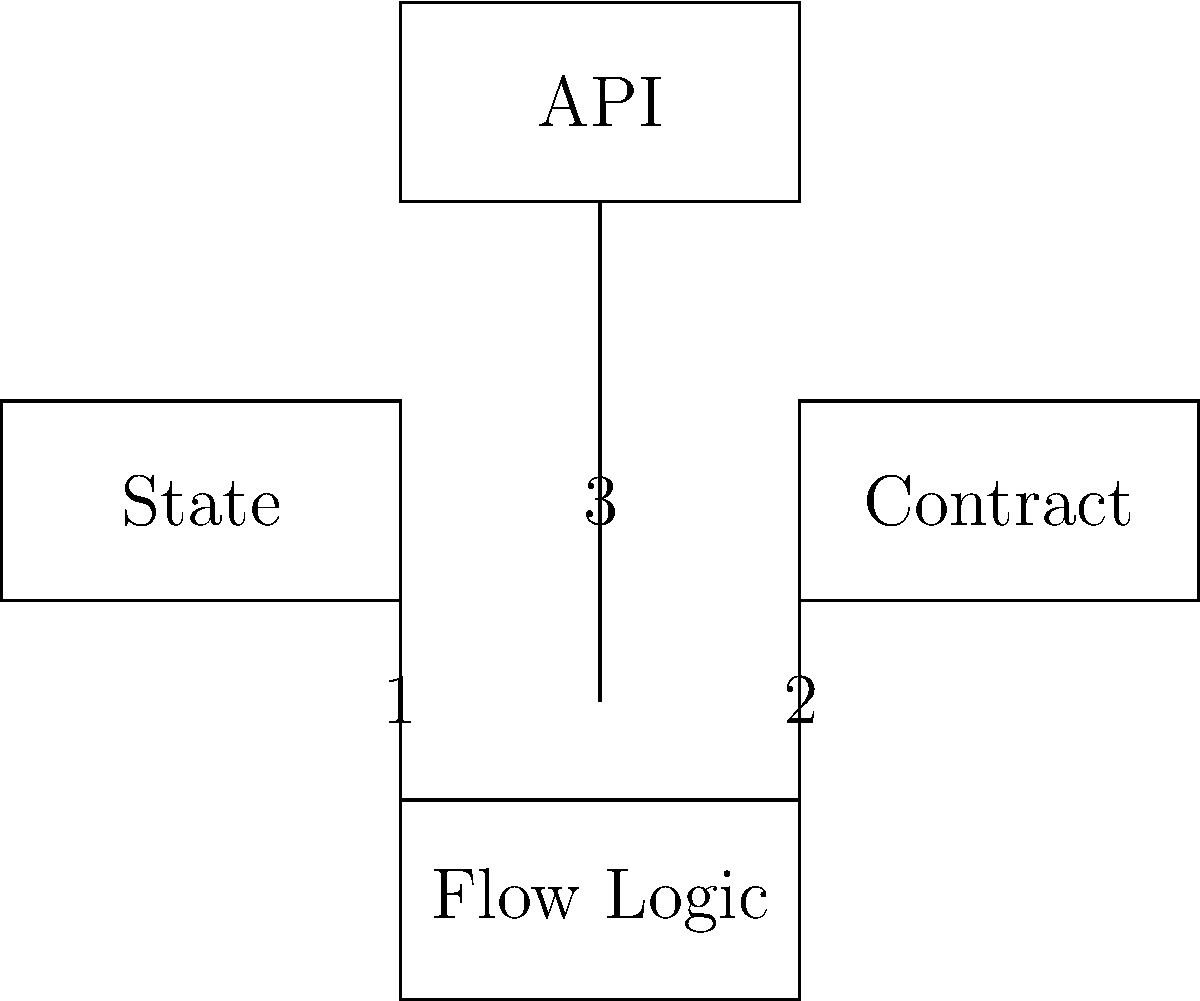In the diagram representing the components of a CorDapp, what is the correct sequence of interactions between the components during a typical transaction flow? To understand the sequence of interactions in a CorDapp transaction flow, let's break it down step-by-step:

1. The process typically starts with the API component. This is where external systems or users interact with the CorDapp, initiating a transaction.

2. From the API, the request is passed down to the Flow Logic. The Flow Logic is responsible for orchestrating the transaction process.

3. The Flow Logic interacts with the State component (labeled as "1" in the diagram). States represent the current facts known by the node and are used to create and validate transactions.

4. Next, the Flow Logic interacts with the Contract component (labeled as "2" in the diagram). Contracts define the rules for how states can be created, consumed, or modified in a transaction.

5. The Flow Logic continues to coordinate between States and Contracts as necessary to build and validate the transaction.

6. Once the transaction is built and validated locally, the Flow Logic communicates back to the API (labeled as "3" in the diagram) to report the result or to initiate further actions like signing or notarizing the transaction.

This sequence ensures that all components work together to create a valid transaction that adheres to the rules defined in the CorDapp.
Answer: API → Flow Logic → State → Contract → Flow Logic → API 